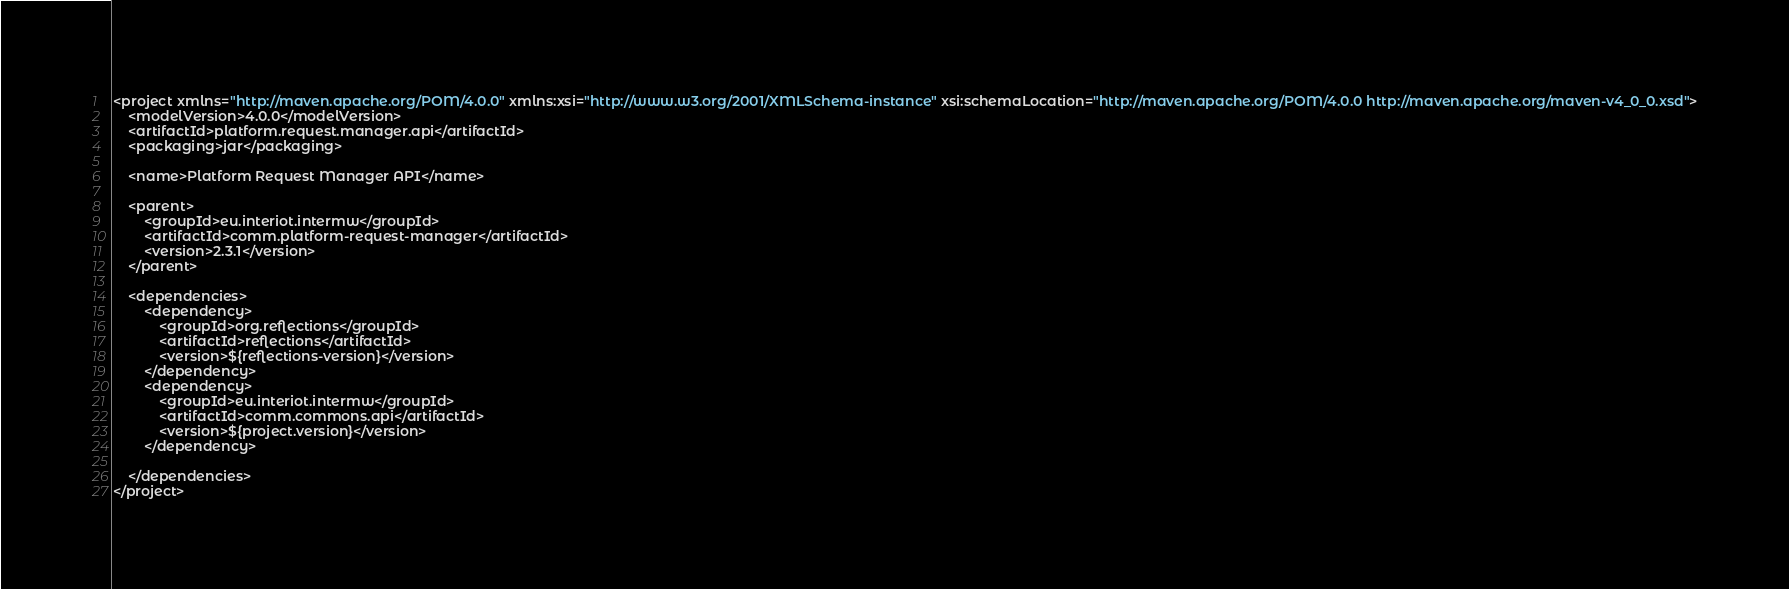<code> <loc_0><loc_0><loc_500><loc_500><_XML_><project xmlns="http://maven.apache.org/POM/4.0.0" xmlns:xsi="http://www.w3.org/2001/XMLSchema-instance" xsi:schemaLocation="http://maven.apache.org/POM/4.0.0 http://maven.apache.org/maven-v4_0_0.xsd">
    <modelVersion>4.0.0</modelVersion>
    <artifactId>platform.request.manager.api</artifactId>
    <packaging>jar</packaging>

    <name>Platform Request Manager API</name>

    <parent>
        <groupId>eu.interiot.intermw</groupId>
        <artifactId>comm.platform-request-manager</artifactId>
        <version>2.3.1</version>
    </parent>

    <dependencies>
        <dependency>
            <groupId>org.reflections</groupId>
            <artifactId>reflections</artifactId>
            <version>${reflections-version}</version>
        </dependency>
        <dependency>
            <groupId>eu.interiot.intermw</groupId>
            <artifactId>comm.commons.api</artifactId>
            <version>${project.version}</version>
        </dependency>

    </dependencies>
</project>
</code> 